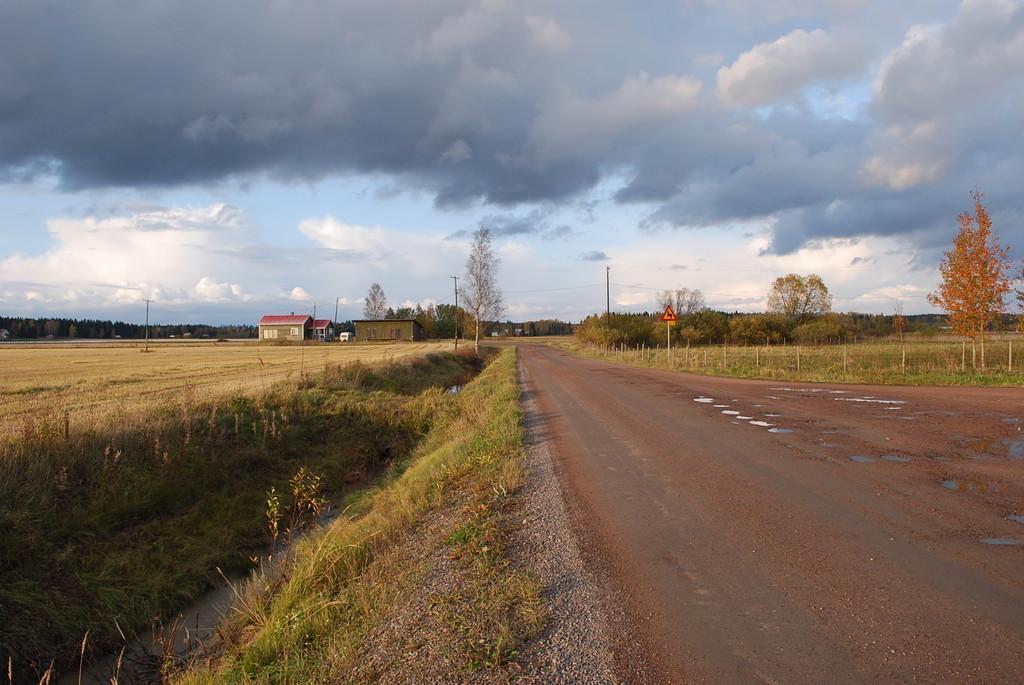In one or two sentences, can you explain what this image depicts? We can see plants, grass, road, water, board on pole and poles. In the background we can see current polls, houses, trees and sky with clouds. 